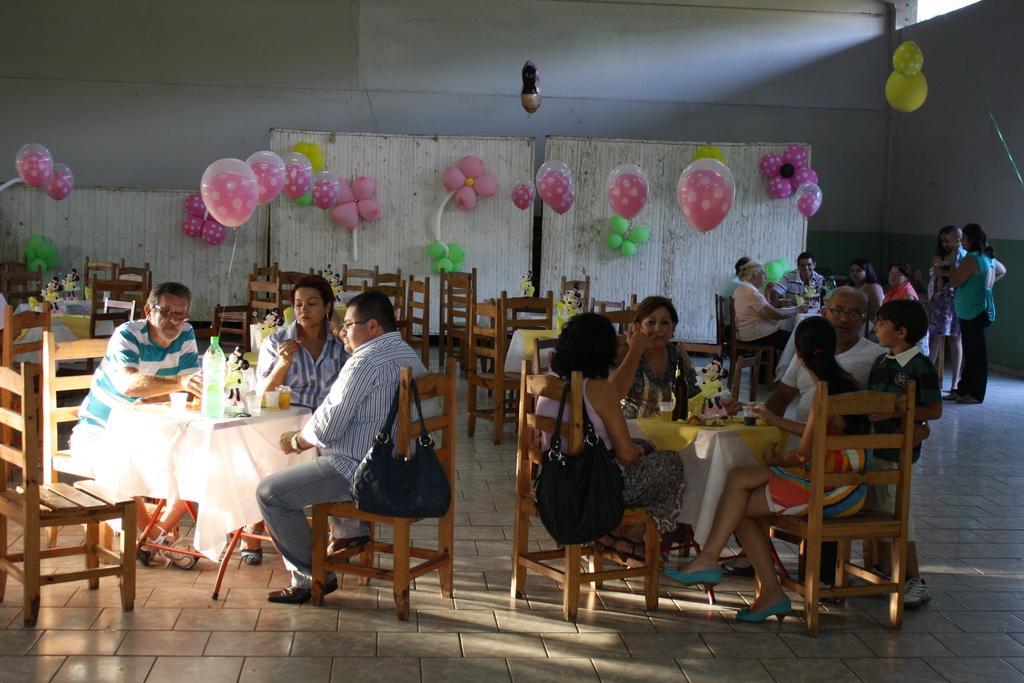In one or two sentences, can you explain what this image depicts? Here we can see group of people sitting on chairs with tables in front of them having cold drinks on them and in the middle we can see handbags hanged on the chair and behind them we can see balloons probably decorated and at the right side we can see some people standing 